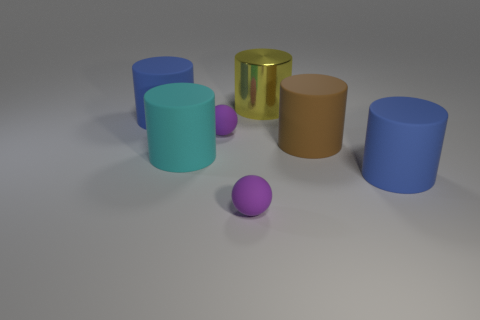Can you describe the arrangement of objects based on their sizes? Sure! The objects are a mix of cylinders and spheres of varying sizes. One of the smallest items is a purple sphere, and it sits in front of a medium-sized blue cylinder. Towards the back, there's a larger tan cylinder, and to its left, there is a smaller gold cylinder, which appears to have a reflective surface. 